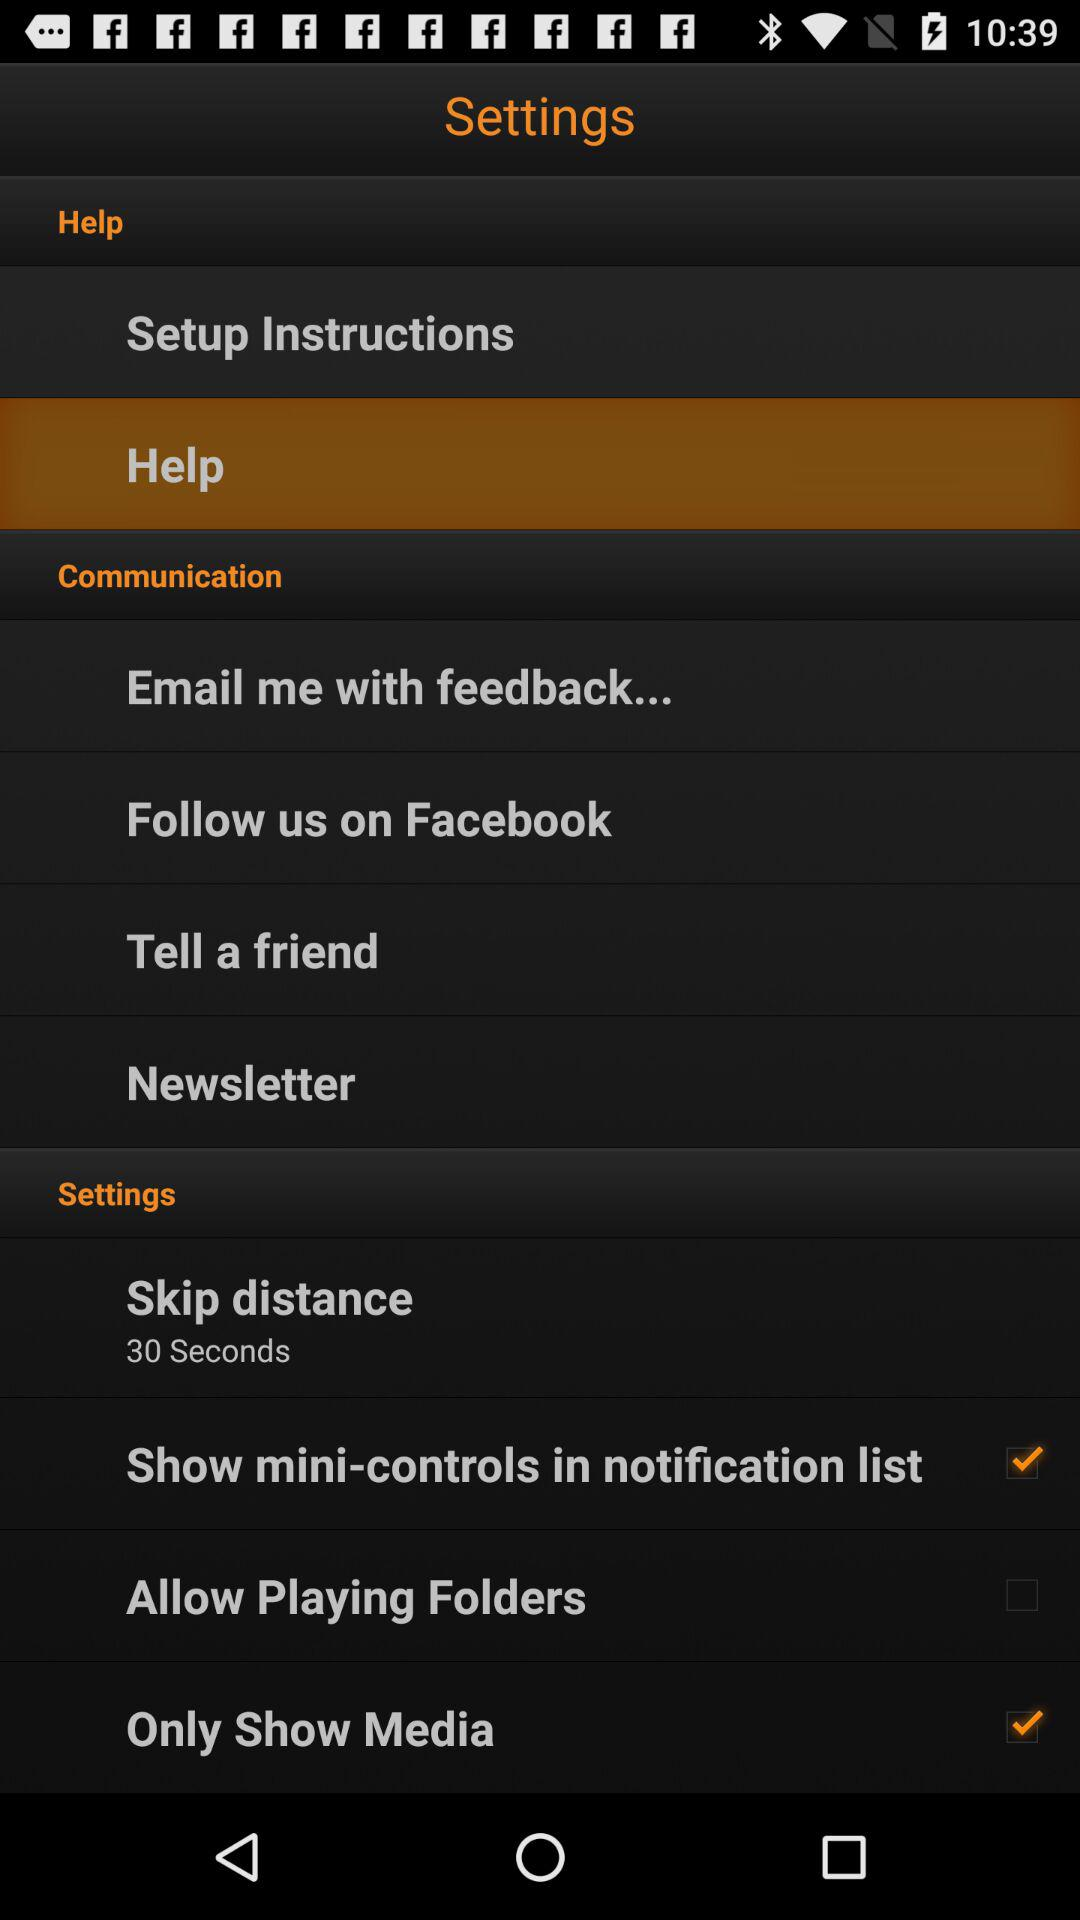What choices can I use for the communication process? The choices are "Email me with feedback...", "Follow us on Facebook", "Tell a friend" and "Newsletter". 